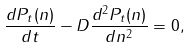<formula> <loc_0><loc_0><loc_500><loc_500>\frac { d P _ { t } ( n ) } { d t } - D \frac { d ^ { 2 } P _ { t } ( n ) } { d n ^ { 2 } } = 0 ,</formula> 